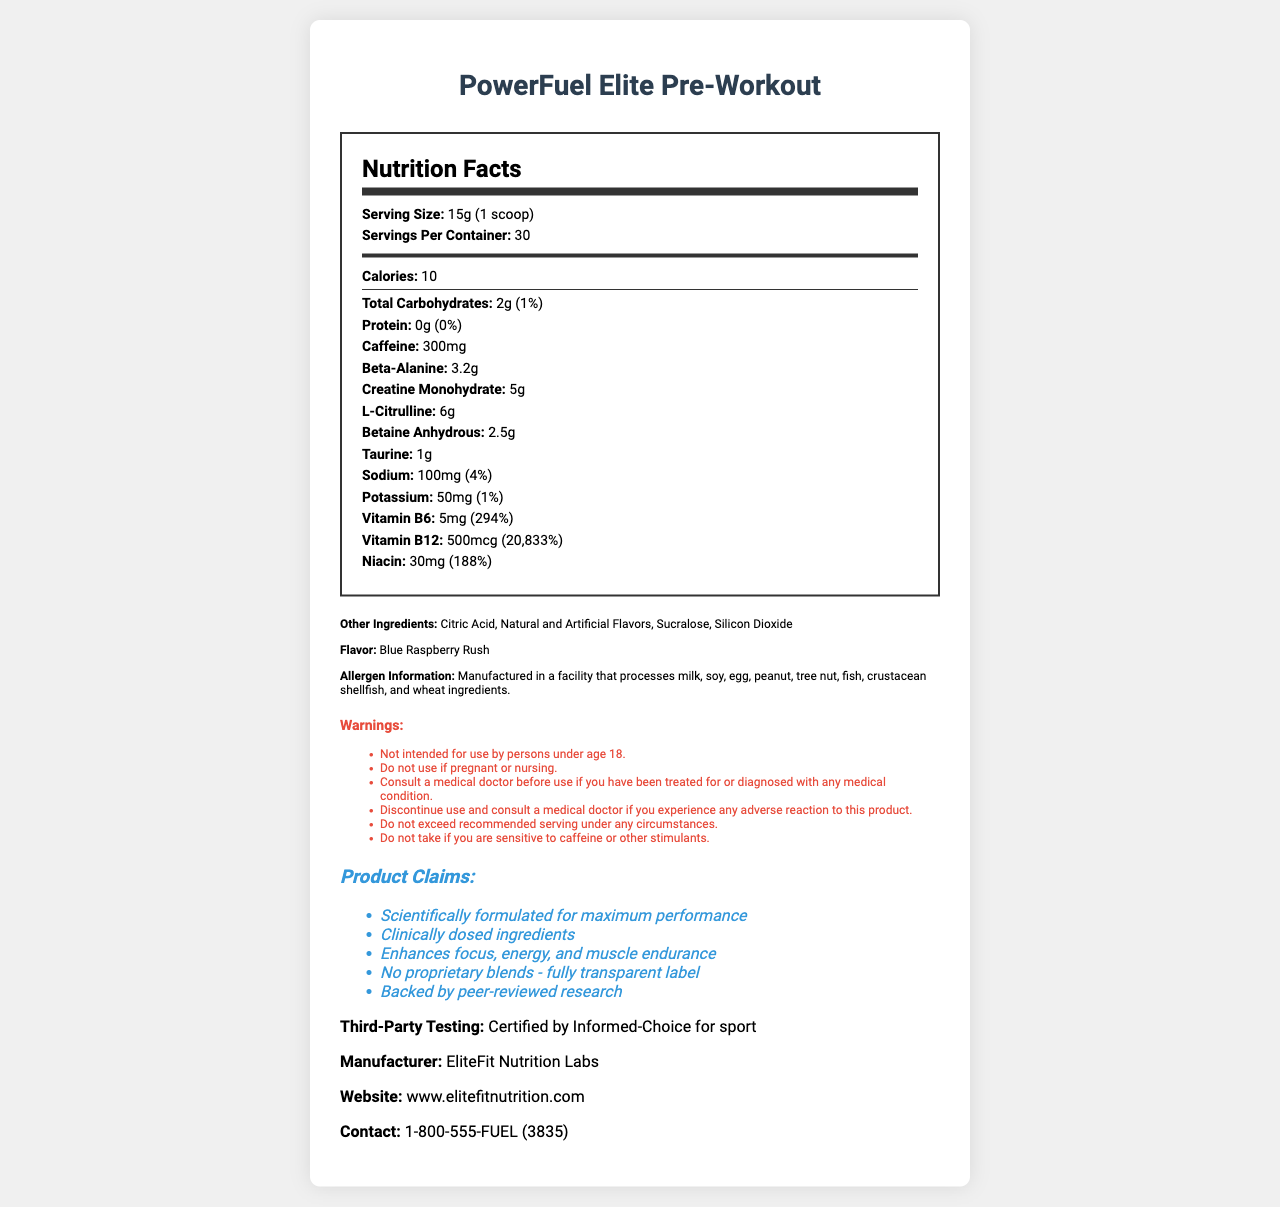what is the serving size of PowerFuel Elite Pre-Workout? The serving size is specified as 15g (1 scoop) in the Nutrition Facts section.
Answer: 15g (1 scoop) how much caffeine is in one serving? The Nutrition Facts label lists the caffeine content as 300mg per serving.
Answer: 300mg how many servings are in one container? The document states that there are 30 servings per container.
Answer: 30 what is the amount of beta-alanine per serving? The amount of beta-alanine per serving is mentioned as 3.2g in the nutrition details.
Answer: 3.2g what is the main flavor of the supplement? The flavor is specified as Blue Raspberry Rush in the document.
Answer: Blue Raspberry Rush which ingredient has the highest amount per serving: creatine monohydrate, beta-alanine, or caffeine?
A. Creatine Monohydrate
B. Beta-Alanine 
C. Caffeine
D. Taurine Creatine Monohydrate has 5g per serving, Beta-Alanine has 3.2g, and Caffeine has 300mg (0.3g).
Answer: A. Creatine Monohydrate how many calories are in one serving? A. 5 B. 10 C. 15 D. 20 The Nutrition Facts state that there are 10 calories per serving.
Answer: B. 10 is there any protein in this supplement? The protein amount is listed as 0g, with a daily value of 0%.
Answer: No is this product intended for children under 18? The warnings section clearly states: "Not intended for use by persons under age 18."
Answer: No summarize the main purpose and claims of PowerFuel Elite Pre-Workout powder. The document is focused on the supplementation benefits of PowerFuel Elite Pre-Workout, highlighting its key active ingredients, intended performance enhancements, safety instructions, and claims of scientific backing and third-party testing.
Answer: The PowerFuel Elite Pre-Workout powder is a dietary supplement designed to enhance focus, energy, and muscle endurance during workouts. It contains clinically dosed ingredients like caffeine, beta-alanine, and creatine. The product claims to be scientifically formulated for maximum performance and is certified by Informed-Choice for sport. It also includes a fully transparent label with no proprietary blends. what is the daily value percentage of Vitamin B12 provided per serving? The Nutrition Facts list the daily value percentage of Vitamin B12 as 20,833%.
Answer: 20,833% should you take more than one scoop of this pre-workout powder per day? The directions specifically warn against exceeding one scoop per day.
Answer: No who manufactures PowerFuel Elite Pre-Workout? The manufacturer is listed as EliteFit Nutrition Labs.
Answer: EliteFit Nutrition Labs what are the other ingredients in this product? The additional ingredients are listed under the "Other Ingredients" section.
Answer: Citric Acid, Natural and Artificial Flavors, Sucralose, Silicon Dioxide who should consult a medical doctor before using this product? The warnings section advises anyone treated for or diagnosed with a medical condition to consult a medical doctor before use.
Answer: Persons treated for or diagnosed with any medical condition is the daily value percentage of niacin higher than that of sodium? Niacin's daily value percentage is 188%, whereas sodium's is only 4%.
Answer: Yes where can you find more information about this product? The document lists the website www.elitefitnutrition.com for more information.
Answer: www.elitefitnutrition.com does the document specify whether this product is free of allergens? The document states that it is manufactured in a facility that processes multiple allergens, but it does not confirm if the product is allergen-free.
Answer: No is there information about the effect of consuming the product while pregnant? The warnings state, "Do not use if pregnant or nursing."
Answer: Yes what is the amount of taurine per serving? The Nutrition Facts label indicates that there is 1g of taurine per serving.
Answer: 1g 